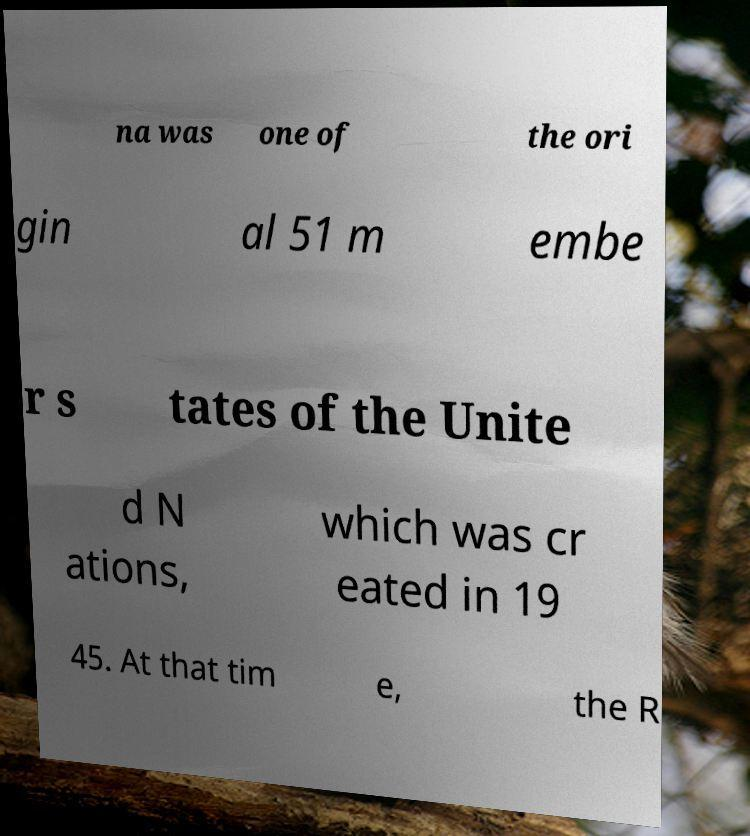I need the written content from this picture converted into text. Can you do that? na was one of the ori gin al 51 m embe r s tates of the Unite d N ations, which was cr eated in 19 45. At that tim e, the R 